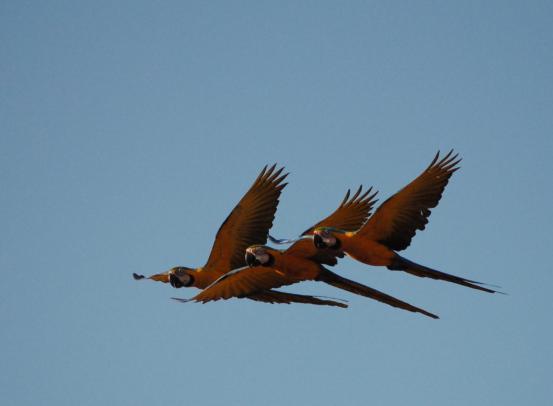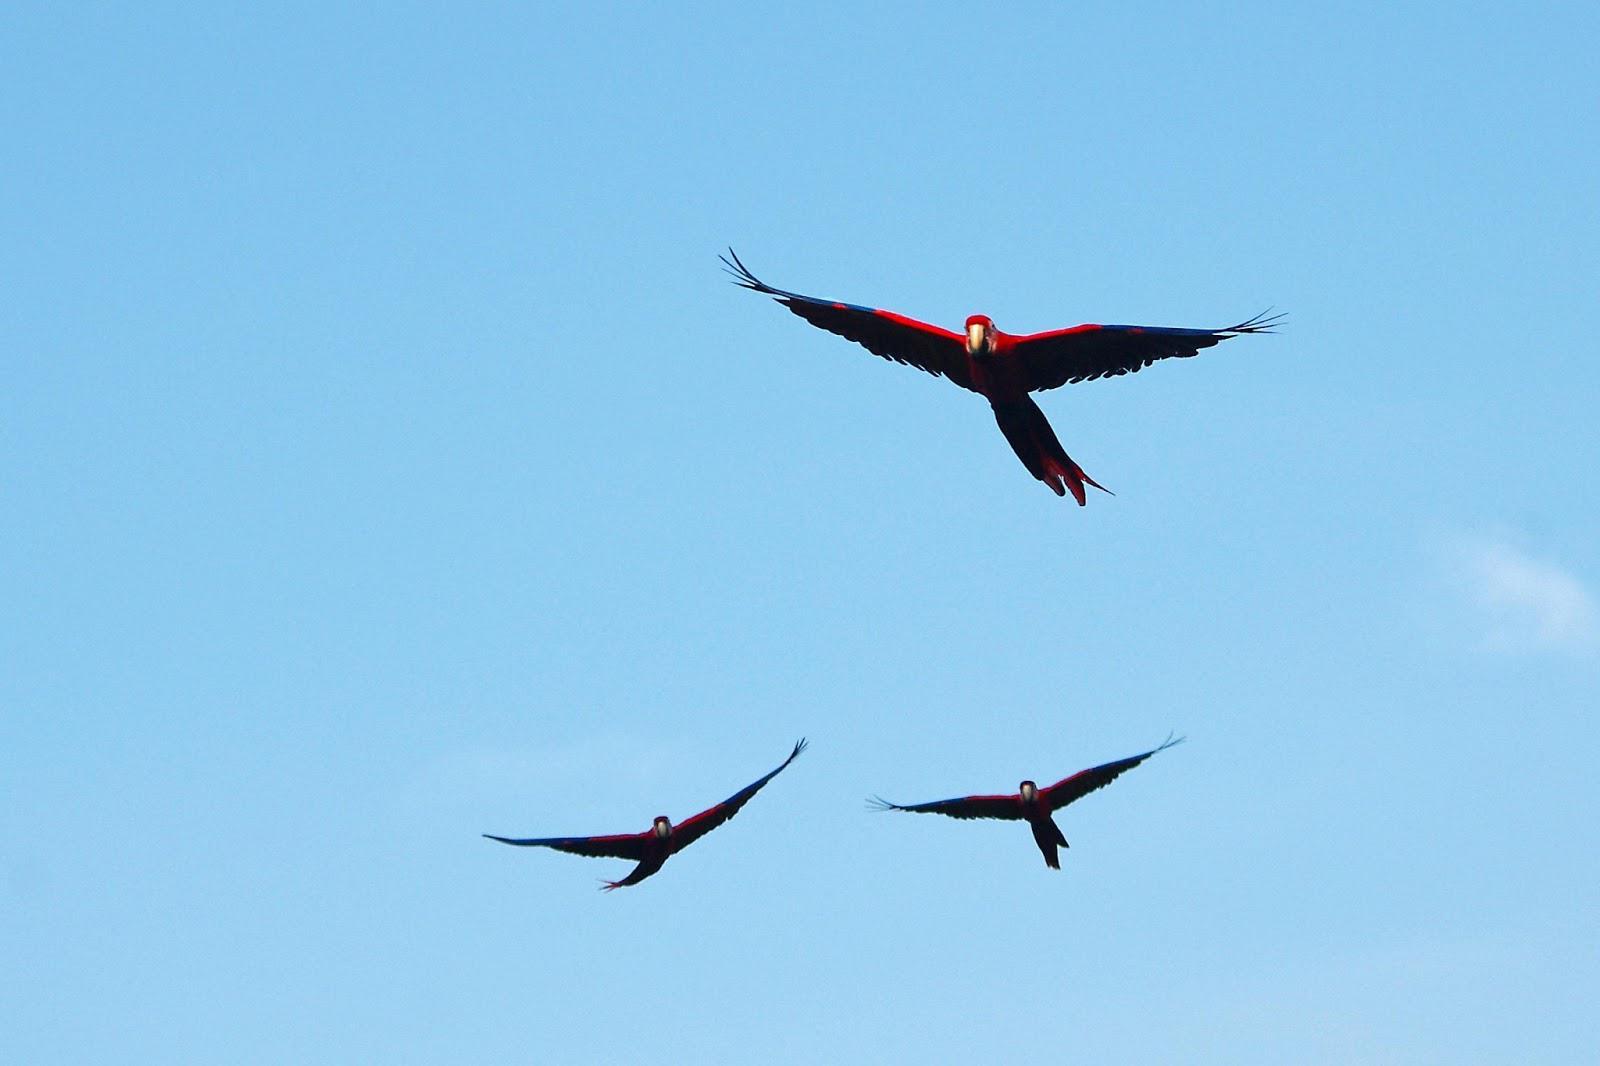The first image is the image on the left, the second image is the image on the right. Assess this claim about the two images: "There are 4 or more parrots flying to the right.". Correct or not? Answer yes or no. No. 